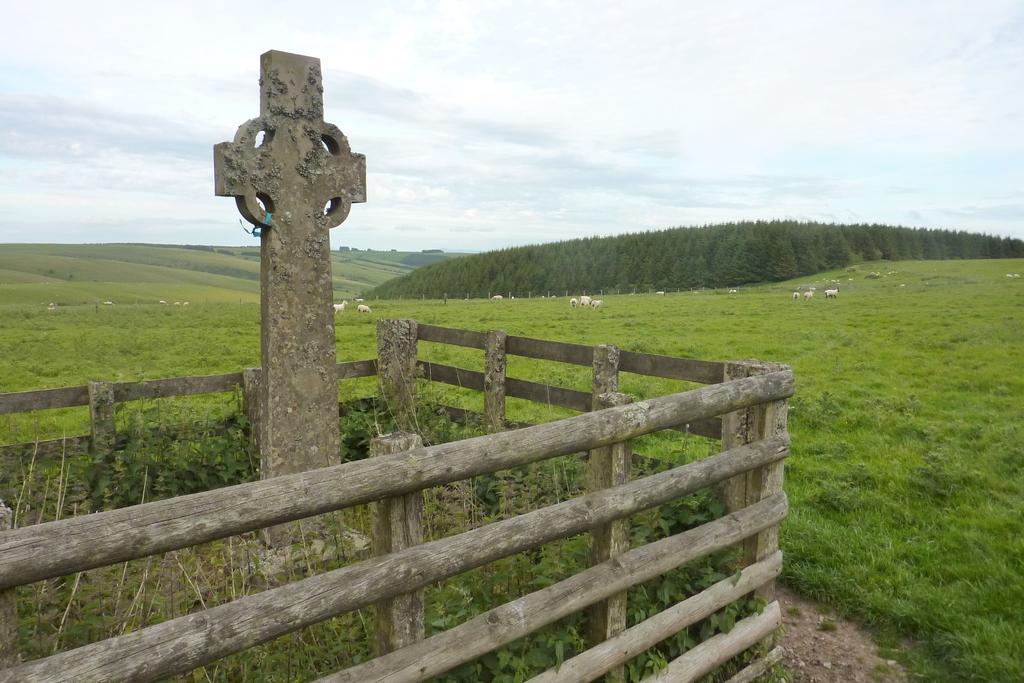In one or two sentences, can you explain what this image depicts? This picture describe about the bamboo fencing and a cross mark in the middle of the fencing area. Behind we can see grass field with white color sheep eating grass. In the background there are many huge trees. 